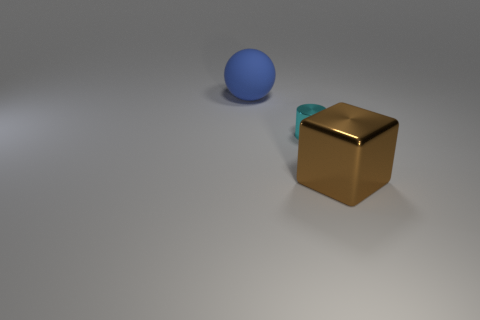What is the shape of the big object in front of the big thing behind the large thing that is right of the small shiny object?
Give a very brief answer. Cube. What shape is the object that is both behind the big metallic cube and right of the blue matte thing?
Your answer should be very brief. Cylinder. How many things are spheres or big things that are on the left side of the large brown block?
Your answer should be very brief. 1. Is the material of the ball the same as the small cyan cylinder?
Your response must be concise. No. How many other things are there of the same shape as the blue rubber object?
Give a very brief answer. 0. How big is the object that is to the left of the large block and in front of the sphere?
Keep it short and to the point. Small. How many shiny things are either big red things or big brown things?
Offer a terse response. 1. There is a big thing that is right of the blue matte object; is it the same shape as the large object that is behind the big block?
Offer a terse response. No. Is there a blue sphere made of the same material as the large brown cube?
Your response must be concise. No. The large block is what color?
Keep it short and to the point. Brown. 